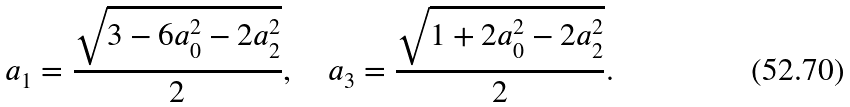<formula> <loc_0><loc_0><loc_500><loc_500>a _ { 1 } = \frac { \sqrt { 3 - 6 a _ { 0 } ^ { 2 } - 2 a _ { 2 } ^ { 2 } } } { 2 } , \quad a _ { 3 } = \frac { \sqrt { 1 + 2 a _ { 0 } ^ { 2 } - 2 a _ { 2 } ^ { 2 } } } { 2 } .</formula> 